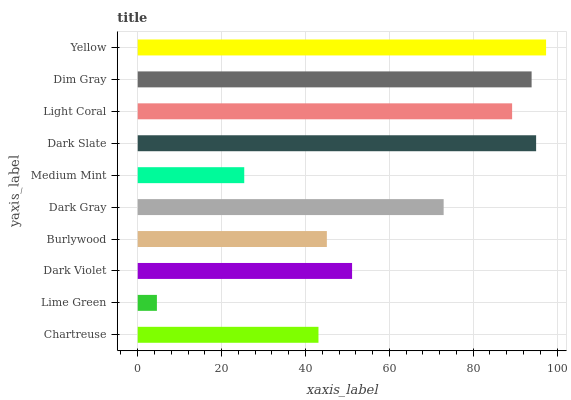Is Lime Green the minimum?
Answer yes or no. Yes. Is Yellow the maximum?
Answer yes or no. Yes. Is Dark Violet the minimum?
Answer yes or no. No. Is Dark Violet the maximum?
Answer yes or no. No. Is Dark Violet greater than Lime Green?
Answer yes or no. Yes. Is Lime Green less than Dark Violet?
Answer yes or no. Yes. Is Lime Green greater than Dark Violet?
Answer yes or no. No. Is Dark Violet less than Lime Green?
Answer yes or no. No. Is Dark Gray the high median?
Answer yes or no. Yes. Is Dark Violet the low median?
Answer yes or no. Yes. Is Light Coral the high median?
Answer yes or no. No. Is Medium Mint the low median?
Answer yes or no. No. 